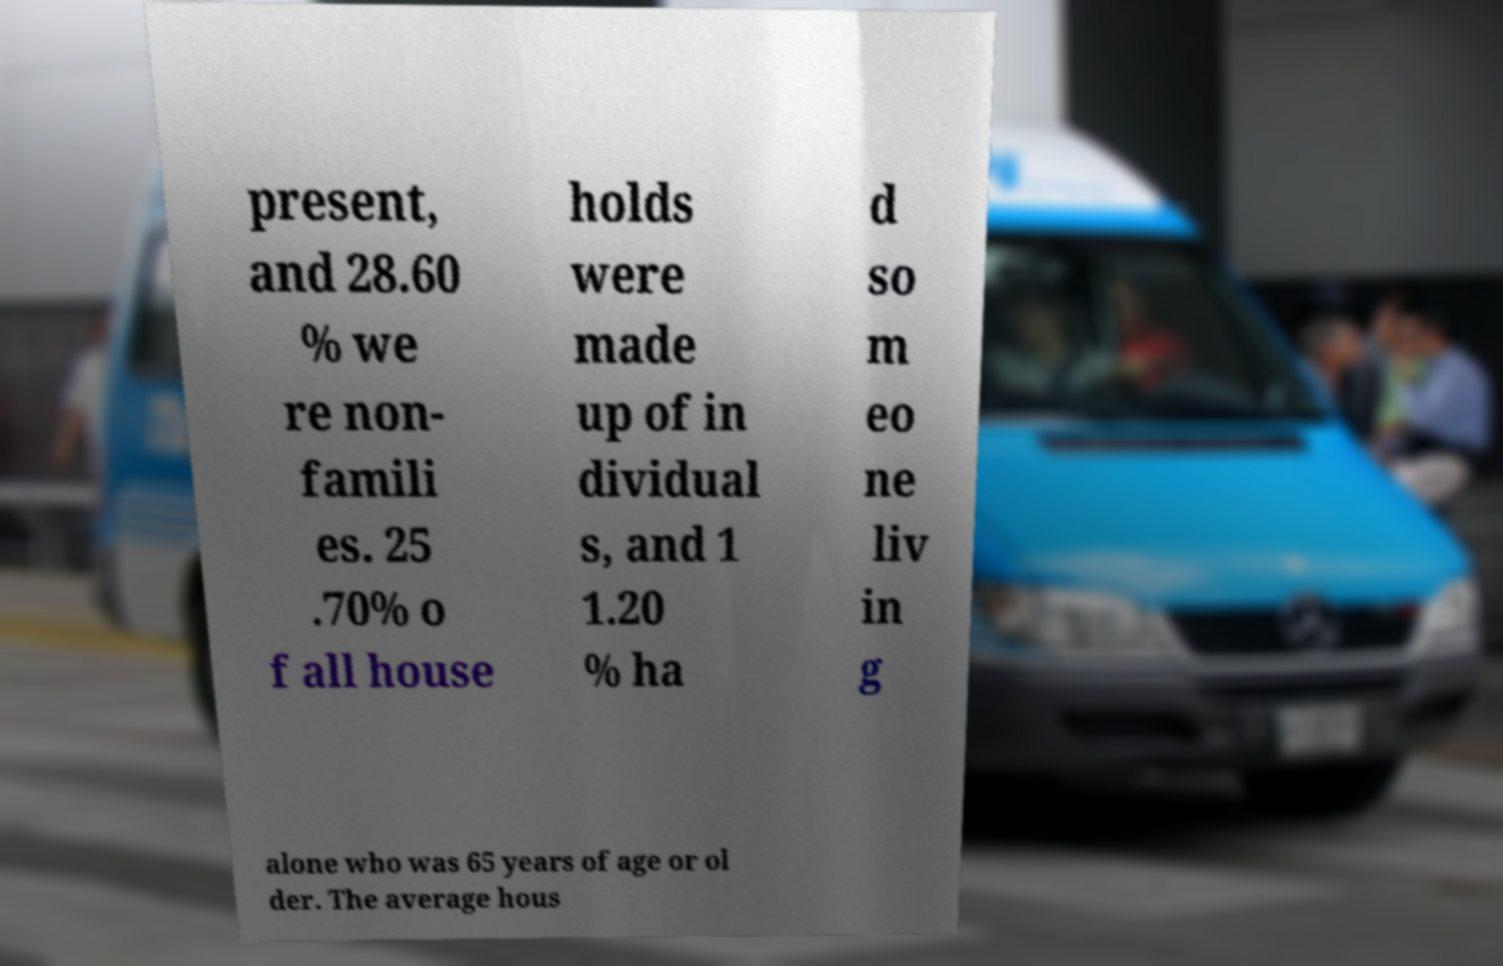Please identify and transcribe the text found in this image. present, and 28.60 % we re non- famili es. 25 .70% o f all house holds were made up of in dividual s, and 1 1.20 % ha d so m eo ne liv in g alone who was 65 years of age or ol der. The average hous 